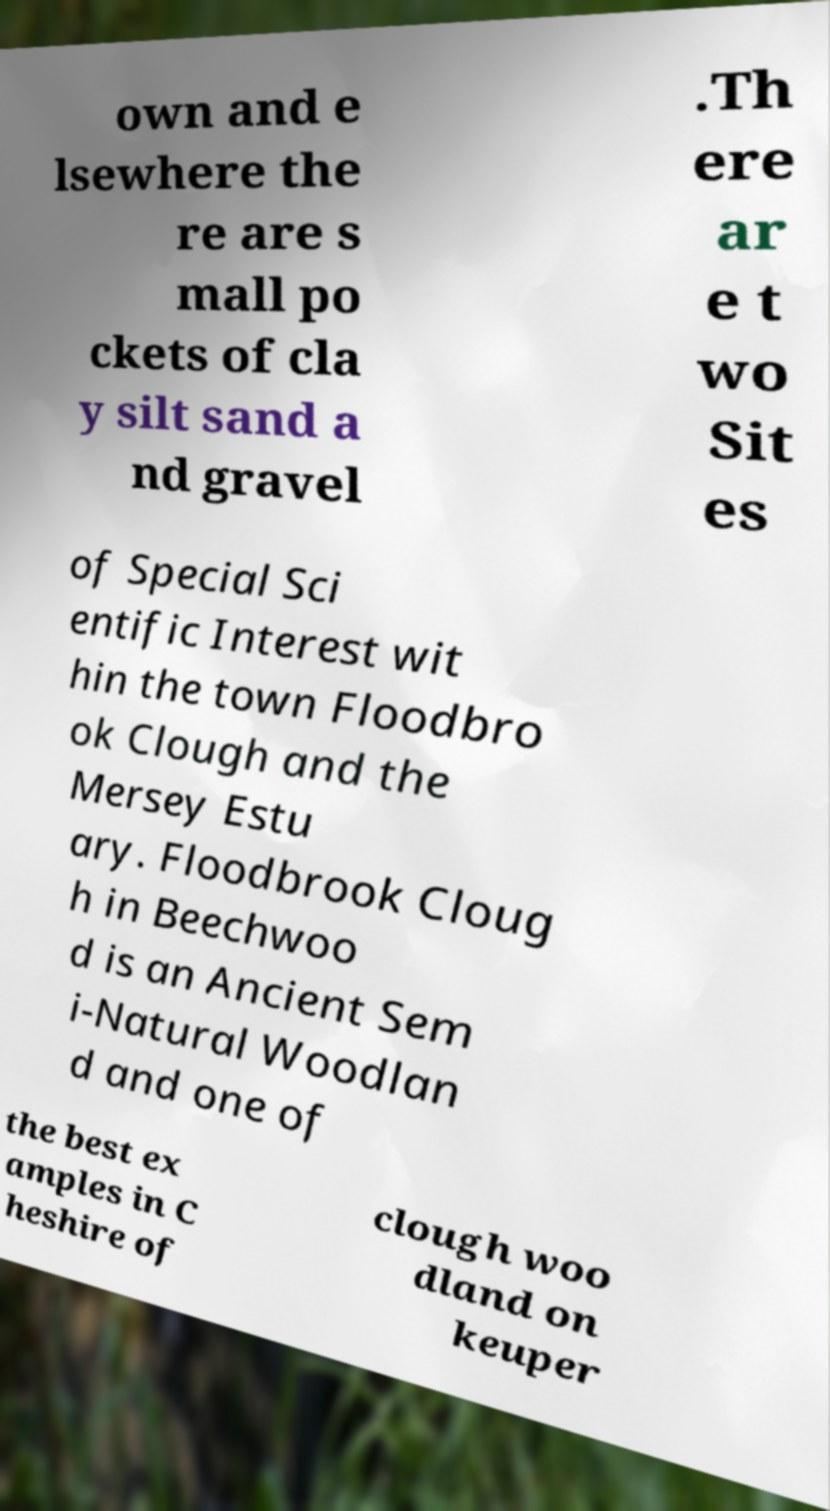Could you assist in decoding the text presented in this image and type it out clearly? own and e lsewhere the re are s mall po ckets of cla y silt sand a nd gravel .Th ere ar e t wo Sit es of Special Sci entific Interest wit hin the town Floodbro ok Clough and the Mersey Estu ary. Floodbrook Cloug h in Beechwoo d is an Ancient Sem i-Natural Woodlan d and one of the best ex amples in C heshire of clough woo dland on keuper 